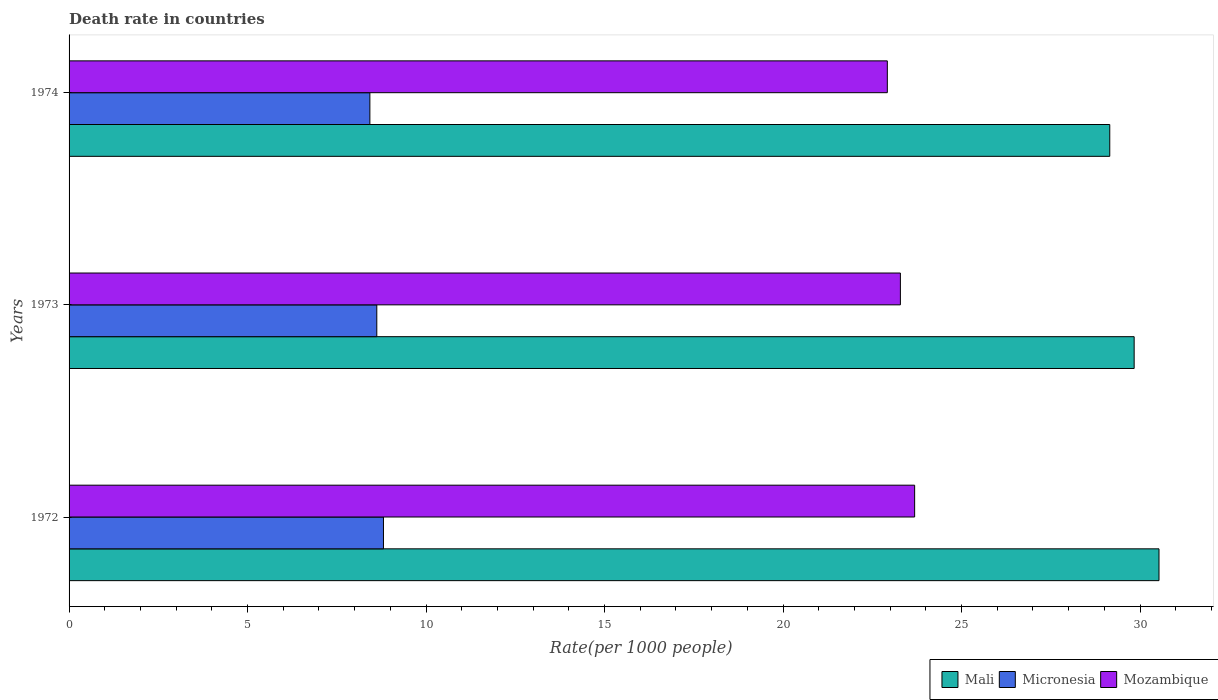How many different coloured bars are there?
Your answer should be very brief. 3. How many groups of bars are there?
Ensure brevity in your answer.  3. Are the number of bars per tick equal to the number of legend labels?
Your response must be concise. Yes. How many bars are there on the 3rd tick from the top?
Give a very brief answer. 3. What is the label of the 1st group of bars from the top?
Give a very brief answer. 1974. In how many cases, is the number of bars for a given year not equal to the number of legend labels?
Make the answer very short. 0. What is the death rate in Mali in 1972?
Give a very brief answer. 30.53. Across all years, what is the maximum death rate in Micronesia?
Give a very brief answer. 8.81. Across all years, what is the minimum death rate in Mozambique?
Keep it short and to the point. 22.92. In which year was the death rate in Mali maximum?
Ensure brevity in your answer.  1972. In which year was the death rate in Mali minimum?
Your answer should be very brief. 1974. What is the total death rate in Mali in the graph?
Ensure brevity in your answer.  89.52. What is the difference between the death rate in Micronesia in 1972 and that in 1973?
Give a very brief answer. 0.19. What is the difference between the death rate in Micronesia in 1972 and the death rate in Mali in 1974?
Keep it short and to the point. -20.34. What is the average death rate in Mozambique per year?
Your answer should be very brief. 23.3. In the year 1974, what is the difference between the death rate in Mali and death rate in Mozambique?
Provide a short and direct response. 6.23. In how many years, is the death rate in Mali greater than 6 ?
Ensure brevity in your answer.  3. What is the ratio of the death rate in Mali in 1972 to that in 1973?
Offer a terse response. 1.02. Is the death rate in Mali in 1972 less than that in 1974?
Your response must be concise. No. Is the difference between the death rate in Mali in 1972 and 1973 greater than the difference between the death rate in Mozambique in 1972 and 1973?
Your response must be concise. Yes. What is the difference between the highest and the second highest death rate in Mozambique?
Give a very brief answer. 0.4. What is the difference between the highest and the lowest death rate in Micronesia?
Offer a very short reply. 0.38. What does the 3rd bar from the top in 1973 represents?
Provide a short and direct response. Mali. What does the 1st bar from the bottom in 1974 represents?
Offer a terse response. Mali. How many bars are there?
Offer a terse response. 9. How many years are there in the graph?
Give a very brief answer. 3. What is the difference between two consecutive major ticks on the X-axis?
Offer a terse response. 5. Are the values on the major ticks of X-axis written in scientific E-notation?
Offer a very short reply. No. Does the graph contain grids?
Your answer should be very brief. No. What is the title of the graph?
Your answer should be compact. Death rate in countries. Does "Romania" appear as one of the legend labels in the graph?
Ensure brevity in your answer.  No. What is the label or title of the X-axis?
Provide a succinct answer. Rate(per 1000 people). What is the Rate(per 1000 people) in Mali in 1972?
Provide a succinct answer. 30.53. What is the Rate(per 1000 people) of Micronesia in 1972?
Your response must be concise. 8.81. What is the Rate(per 1000 people) of Mozambique in 1972?
Make the answer very short. 23.69. What is the Rate(per 1000 people) in Mali in 1973?
Ensure brevity in your answer.  29.84. What is the Rate(per 1000 people) of Micronesia in 1973?
Offer a terse response. 8.62. What is the Rate(per 1000 people) in Mozambique in 1973?
Your answer should be very brief. 23.29. What is the Rate(per 1000 people) of Mali in 1974?
Ensure brevity in your answer.  29.15. What is the Rate(per 1000 people) of Micronesia in 1974?
Make the answer very short. 8.43. What is the Rate(per 1000 people) of Mozambique in 1974?
Offer a terse response. 22.92. Across all years, what is the maximum Rate(per 1000 people) of Mali?
Ensure brevity in your answer.  30.53. Across all years, what is the maximum Rate(per 1000 people) of Micronesia?
Offer a terse response. 8.81. Across all years, what is the maximum Rate(per 1000 people) of Mozambique?
Offer a terse response. 23.69. Across all years, what is the minimum Rate(per 1000 people) in Mali?
Make the answer very short. 29.15. Across all years, what is the minimum Rate(per 1000 people) in Micronesia?
Provide a succinct answer. 8.43. Across all years, what is the minimum Rate(per 1000 people) of Mozambique?
Your response must be concise. 22.92. What is the total Rate(per 1000 people) of Mali in the graph?
Your response must be concise. 89.52. What is the total Rate(per 1000 people) of Micronesia in the graph?
Your answer should be very brief. 25.85. What is the total Rate(per 1000 people) in Mozambique in the graph?
Provide a short and direct response. 69.89. What is the difference between the Rate(per 1000 people) of Mali in 1972 and that in 1973?
Your answer should be compact. 0.7. What is the difference between the Rate(per 1000 people) of Micronesia in 1972 and that in 1973?
Offer a terse response. 0.19. What is the difference between the Rate(per 1000 people) of Mozambique in 1972 and that in 1973?
Your answer should be very brief. 0.4. What is the difference between the Rate(per 1000 people) of Mali in 1972 and that in 1974?
Make the answer very short. 1.38. What is the difference between the Rate(per 1000 people) of Micronesia in 1972 and that in 1974?
Your answer should be compact. 0.38. What is the difference between the Rate(per 1000 people) of Mozambique in 1972 and that in 1974?
Your answer should be compact. 0.77. What is the difference between the Rate(per 1000 people) of Mali in 1973 and that in 1974?
Provide a short and direct response. 0.68. What is the difference between the Rate(per 1000 people) of Micronesia in 1973 and that in 1974?
Make the answer very short. 0.19. What is the difference between the Rate(per 1000 people) in Mozambique in 1973 and that in 1974?
Give a very brief answer. 0.37. What is the difference between the Rate(per 1000 people) of Mali in 1972 and the Rate(per 1000 people) of Micronesia in 1973?
Your response must be concise. 21.91. What is the difference between the Rate(per 1000 people) in Mali in 1972 and the Rate(per 1000 people) in Mozambique in 1973?
Make the answer very short. 7.24. What is the difference between the Rate(per 1000 people) of Micronesia in 1972 and the Rate(per 1000 people) of Mozambique in 1973?
Your response must be concise. -14.48. What is the difference between the Rate(per 1000 people) of Mali in 1972 and the Rate(per 1000 people) of Micronesia in 1974?
Offer a very short reply. 22.11. What is the difference between the Rate(per 1000 people) in Mali in 1972 and the Rate(per 1000 people) in Mozambique in 1974?
Make the answer very short. 7.61. What is the difference between the Rate(per 1000 people) in Micronesia in 1972 and the Rate(per 1000 people) in Mozambique in 1974?
Make the answer very short. -14.11. What is the difference between the Rate(per 1000 people) of Mali in 1973 and the Rate(per 1000 people) of Micronesia in 1974?
Your answer should be very brief. 21.41. What is the difference between the Rate(per 1000 people) in Mali in 1973 and the Rate(per 1000 people) in Mozambique in 1974?
Ensure brevity in your answer.  6.91. What is the difference between the Rate(per 1000 people) of Micronesia in 1973 and the Rate(per 1000 people) of Mozambique in 1974?
Give a very brief answer. -14.3. What is the average Rate(per 1000 people) in Mali per year?
Give a very brief answer. 29.84. What is the average Rate(per 1000 people) in Micronesia per year?
Give a very brief answer. 8.62. What is the average Rate(per 1000 people) in Mozambique per year?
Your answer should be compact. 23.3. In the year 1972, what is the difference between the Rate(per 1000 people) of Mali and Rate(per 1000 people) of Micronesia?
Provide a succinct answer. 21.72. In the year 1972, what is the difference between the Rate(per 1000 people) of Mali and Rate(per 1000 people) of Mozambique?
Offer a very short reply. 6.84. In the year 1972, what is the difference between the Rate(per 1000 people) in Micronesia and Rate(per 1000 people) in Mozambique?
Keep it short and to the point. -14.88. In the year 1973, what is the difference between the Rate(per 1000 people) of Mali and Rate(per 1000 people) of Micronesia?
Provide a short and direct response. 21.21. In the year 1973, what is the difference between the Rate(per 1000 people) of Mali and Rate(per 1000 people) of Mozambique?
Your response must be concise. 6.55. In the year 1973, what is the difference between the Rate(per 1000 people) of Micronesia and Rate(per 1000 people) of Mozambique?
Offer a terse response. -14.67. In the year 1974, what is the difference between the Rate(per 1000 people) in Mali and Rate(per 1000 people) in Micronesia?
Make the answer very short. 20.73. In the year 1974, what is the difference between the Rate(per 1000 people) in Mali and Rate(per 1000 people) in Mozambique?
Give a very brief answer. 6.23. In the year 1974, what is the difference between the Rate(per 1000 people) of Micronesia and Rate(per 1000 people) of Mozambique?
Keep it short and to the point. -14.49. What is the ratio of the Rate(per 1000 people) of Mali in 1972 to that in 1973?
Your answer should be compact. 1.02. What is the ratio of the Rate(per 1000 people) in Micronesia in 1972 to that in 1973?
Make the answer very short. 1.02. What is the ratio of the Rate(per 1000 people) in Mozambique in 1972 to that in 1973?
Give a very brief answer. 1.02. What is the ratio of the Rate(per 1000 people) in Mali in 1972 to that in 1974?
Make the answer very short. 1.05. What is the ratio of the Rate(per 1000 people) in Micronesia in 1972 to that in 1974?
Your answer should be compact. 1.05. What is the ratio of the Rate(per 1000 people) in Mozambique in 1972 to that in 1974?
Your answer should be very brief. 1.03. What is the ratio of the Rate(per 1000 people) in Mali in 1973 to that in 1974?
Give a very brief answer. 1.02. What is the ratio of the Rate(per 1000 people) of Micronesia in 1973 to that in 1974?
Your response must be concise. 1.02. What is the difference between the highest and the second highest Rate(per 1000 people) in Mali?
Keep it short and to the point. 0.7. What is the difference between the highest and the second highest Rate(per 1000 people) in Micronesia?
Give a very brief answer. 0.19. What is the difference between the highest and the second highest Rate(per 1000 people) in Mozambique?
Make the answer very short. 0.4. What is the difference between the highest and the lowest Rate(per 1000 people) in Mali?
Provide a succinct answer. 1.38. What is the difference between the highest and the lowest Rate(per 1000 people) in Micronesia?
Give a very brief answer. 0.38. What is the difference between the highest and the lowest Rate(per 1000 people) in Mozambique?
Make the answer very short. 0.77. 